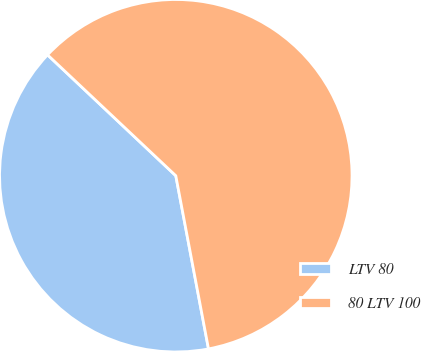Convert chart. <chart><loc_0><loc_0><loc_500><loc_500><pie_chart><fcel>LTV 80<fcel>80 LTV 100<nl><fcel>40.0%<fcel>60.0%<nl></chart> 